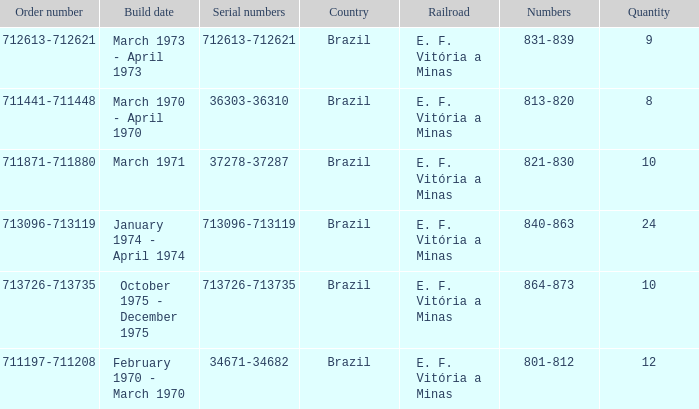The numbers 801-812 are in which country? Brazil. 